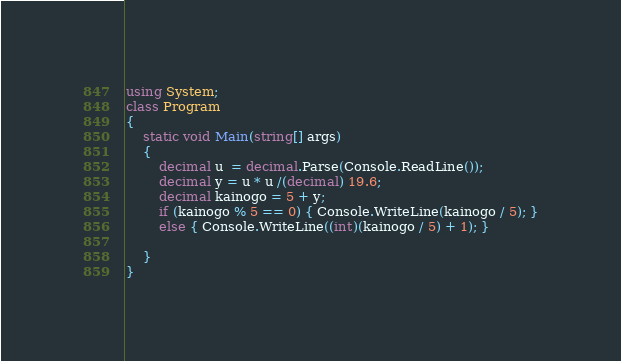<code> <loc_0><loc_0><loc_500><loc_500><_C#_>using System;
class Program
{
    static void Main(string[] args)
    {
        decimal u  = decimal.Parse(Console.ReadLine());
        decimal y = u * u /(decimal) 19.6;
        decimal kainogo = 5 + y;
        if (kainogo % 5 == 0) { Console.WriteLine(kainogo / 5); }
        else { Console.WriteLine((int)(kainogo / 5) + 1); }

    }
}</code> 